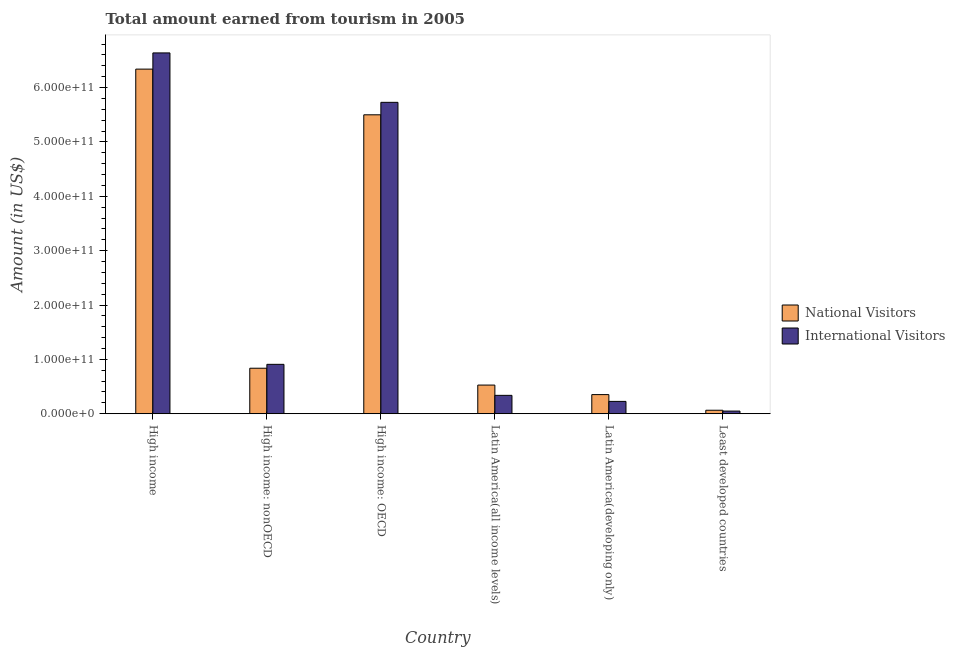How many different coloured bars are there?
Your answer should be very brief. 2. How many groups of bars are there?
Give a very brief answer. 6. Are the number of bars on each tick of the X-axis equal?
Your response must be concise. Yes. What is the label of the 4th group of bars from the left?
Make the answer very short. Latin America(all income levels). In how many cases, is the number of bars for a given country not equal to the number of legend labels?
Offer a terse response. 0. What is the amount earned from international visitors in Latin America(developing only)?
Ensure brevity in your answer.  2.27e+1. Across all countries, what is the maximum amount earned from international visitors?
Provide a succinct answer. 6.64e+11. Across all countries, what is the minimum amount earned from international visitors?
Offer a very short reply. 4.90e+09. In which country was the amount earned from international visitors minimum?
Your answer should be very brief. Least developed countries. What is the total amount earned from international visitors in the graph?
Keep it short and to the point. 1.39e+12. What is the difference between the amount earned from international visitors in High income: nonOECD and that in Latin America(developing only)?
Ensure brevity in your answer.  6.82e+1. What is the difference between the amount earned from international visitors in Latin America(developing only) and the amount earned from national visitors in High income: nonOECD?
Provide a short and direct response. -6.10e+1. What is the average amount earned from international visitors per country?
Ensure brevity in your answer.  2.31e+11. What is the difference between the amount earned from national visitors and amount earned from international visitors in Latin America(all income levels)?
Your answer should be very brief. 1.89e+1. What is the ratio of the amount earned from international visitors in High income to that in Latin America(all income levels)?
Your answer should be compact. 19.63. Is the amount earned from international visitors in High income less than that in High income: nonOECD?
Your answer should be very brief. No. Is the difference between the amount earned from national visitors in High income and Latin America(all income levels) greater than the difference between the amount earned from international visitors in High income and Latin America(all income levels)?
Offer a very short reply. No. What is the difference between the highest and the second highest amount earned from international visitors?
Make the answer very short. 9.09e+1. What is the difference between the highest and the lowest amount earned from national visitors?
Provide a succinct answer. 6.28e+11. In how many countries, is the amount earned from international visitors greater than the average amount earned from international visitors taken over all countries?
Keep it short and to the point. 2. Is the sum of the amount earned from national visitors in High income: nonOECD and Latin America(all income levels) greater than the maximum amount earned from international visitors across all countries?
Ensure brevity in your answer.  No. What does the 2nd bar from the left in Latin America(all income levels) represents?
Provide a short and direct response. International Visitors. What does the 2nd bar from the right in High income: nonOECD represents?
Give a very brief answer. National Visitors. Are all the bars in the graph horizontal?
Keep it short and to the point. No. How many countries are there in the graph?
Keep it short and to the point. 6. What is the difference between two consecutive major ticks on the Y-axis?
Your response must be concise. 1.00e+11. Does the graph contain any zero values?
Offer a very short reply. No. Does the graph contain grids?
Provide a succinct answer. No. How many legend labels are there?
Provide a short and direct response. 2. How are the legend labels stacked?
Make the answer very short. Vertical. What is the title of the graph?
Make the answer very short. Total amount earned from tourism in 2005. Does "Highest 20% of population" appear as one of the legend labels in the graph?
Provide a succinct answer. No. What is the label or title of the X-axis?
Your answer should be compact. Country. What is the Amount (in US$) in National Visitors in High income?
Provide a succinct answer. 6.34e+11. What is the Amount (in US$) in International Visitors in High income?
Keep it short and to the point. 6.64e+11. What is the Amount (in US$) of National Visitors in High income: nonOECD?
Offer a terse response. 8.37e+1. What is the Amount (in US$) of International Visitors in High income: nonOECD?
Make the answer very short. 9.09e+1. What is the Amount (in US$) of National Visitors in High income: OECD?
Offer a very short reply. 5.50e+11. What is the Amount (in US$) in International Visitors in High income: OECD?
Offer a very short reply. 5.73e+11. What is the Amount (in US$) in National Visitors in Latin America(all income levels)?
Offer a terse response. 5.27e+1. What is the Amount (in US$) in International Visitors in Latin America(all income levels)?
Provide a short and direct response. 3.38e+1. What is the Amount (in US$) in National Visitors in Latin America(developing only)?
Keep it short and to the point. 3.52e+1. What is the Amount (in US$) in International Visitors in Latin America(developing only)?
Your answer should be very brief. 2.27e+1. What is the Amount (in US$) in National Visitors in Least developed countries?
Make the answer very short. 6.44e+09. What is the Amount (in US$) of International Visitors in Least developed countries?
Offer a terse response. 4.90e+09. Across all countries, what is the maximum Amount (in US$) in National Visitors?
Your response must be concise. 6.34e+11. Across all countries, what is the maximum Amount (in US$) in International Visitors?
Keep it short and to the point. 6.64e+11. Across all countries, what is the minimum Amount (in US$) of National Visitors?
Offer a terse response. 6.44e+09. Across all countries, what is the minimum Amount (in US$) in International Visitors?
Offer a terse response. 4.90e+09. What is the total Amount (in US$) of National Visitors in the graph?
Your response must be concise. 1.36e+12. What is the total Amount (in US$) in International Visitors in the graph?
Give a very brief answer. 1.39e+12. What is the difference between the Amount (in US$) of National Visitors in High income and that in High income: nonOECD?
Offer a terse response. 5.50e+11. What is the difference between the Amount (in US$) in International Visitors in High income and that in High income: nonOECD?
Your response must be concise. 5.73e+11. What is the difference between the Amount (in US$) in National Visitors in High income and that in High income: OECD?
Keep it short and to the point. 8.40e+1. What is the difference between the Amount (in US$) in International Visitors in High income and that in High income: OECD?
Keep it short and to the point. 9.09e+1. What is the difference between the Amount (in US$) of National Visitors in High income and that in Latin America(all income levels)?
Ensure brevity in your answer.  5.81e+11. What is the difference between the Amount (in US$) of International Visitors in High income and that in Latin America(all income levels)?
Keep it short and to the point. 6.30e+11. What is the difference between the Amount (in US$) of National Visitors in High income and that in Latin America(developing only)?
Provide a succinct answer. 5.99e+11. What is the difference between the Amount (in US$) in International Visitors in High income and that in Latin America(developing only)?
Make the answer very short. 6.41e+11. What is the difference between the Amount (in US$) in National Visitors in High income and that in Least developed countries?
Give a very brief answer. 6.28e+11. What is the difference between the Amount (in US$) in International Visitors in High income and that in Least developed countries?
Your response must be concise. 6.59e+11. What is the difference between the Amount (in US$) in National Visitors in High income: nonOECD and that in High income: OECD?
Your answer should be compact. -4.66e+11. What is the difference between the Amount (in US$) of International Visitors in High income: nonOECD and that in High income: OECD?
Make the answer very short. -4.82e+11. What is the difference between the Amount (in US$) in National Visitors in High income: nonOECD and that in Latin America(all income levels)?
Keep it short and to the point. 3.10e+1. What is the difference between the Amount (in US$) of International Visitors in High income: nonOECD and that in Latin America(all income levels)?
Keep it short and to the point. 5.71e+1. What is the difference between the Amount (in US$) in National Visitors in High income: nonOECD and that in Latin America(developing only)?
Provide a short and direct response. 4.85e+1. What is the difference between the Amount (in US$) of International Visitors in High income: nonOECD and that in Latin America(developing only)?
Provide a short and direct response. 6.82e+1. What is the difference between the Amount (in US$) in National Visitors in High income: nonOECD and that in Least developed countries?
Make the answer very short. 7.73e+1. What is the difference between the Amount (in US$) in International Visitors in High income: nonOECD and that in Least developed countries?
Your answer should be very brief. 8.60e+1. What is the difference between the Amount (in US$) in National Visitors in High income: OECD and that in Latin America(all income levels)?
Your answer should be compact. 4.97e+11. What is the difference between the Amount (in US$) of International Visitors in High income: OECD and that in Latin America(all income levels)?
Your answer should be very brief. 5.39e+11. What is the difference between the Amount (in US$) of National Visitors in High income: OECD and that in Latin America(developing only)?
Make the answer very short. 5.15e+11. What is the difference between the Amount (in US$) of International Visitors in High income: OECD and that in Latin America(developing only)?
Keep it short and to the point. 5.50e+11. What is the difference between the Amount (in US$) in National Visitors in High income: OECD and that in Least developed countries?
Provide a succinct answer. 5.43e+11. What is the difference between the Amount (in US$) in International Visitors in High income: OECD and that in Least developed countries?
Give a very brief answer. 5.68e+11. What is the difference between the Amount (in US$) in National Visitors in Latin America(all income levels) and that in Latin America(developing only)?
Offer a terse response. 1.75e+1. What is the difference between the Amount (in US$) in International Visitors in Latin America(all income levels) and that in Latin America(developing only)?
Your answer should be compact. 1.11e+1. What is the difference between the Amount (in US$) in National Visitors in Latin America(all income levels) and that in Least developed countries?
Give a very brief answer. 4.63e+1. What is the difference between the Amount (in US$) of International Visitors in Latin America(all income levels) and that in Least developed countries?
Ensure brevity in your answer.  2.89e+1. What is the difference between the Amount (in US$) in National Visitors in Latin America(developing only) and that in Least developed countries?
Make the answer very short. 2.88e+1. What is the difference between the Amount (in US$) of International Visitors in Latin America(developing only) and that in Least developed countries?
Ensure brevity in your answer.  1.78e+1. What is the difference between the Amount (in US$) of National Visitors in High income and the Amount (in US$) of International Visitors in High income: nonOECD?
Offer a terse response. 5.43e+11. What is the difference between the Amount (in US$) of National Visitors in High income and the Amount (in US$) of International Visitors in High income: OECD?
Offer a terse response. 6.11e+1. What is the difference between the Amount (in US$) of National Visitors in High income and the Amount (in US$) of International Visitors in Latin America(all income levels)?
Your answer should be compact. 6.00e+11. What is the difference between the Amount (in US$) in National Visitors in High income and the Amount (in US$) in International Visitors in Latin America(developing only)?
Ensure brevity in your answer.  6.11e+11. What is the difference between the Amount (in US$) of National Visitors in High income and the Amount (in US$) of International Visitors in Least developed countries?
Make the answer very short. 6.29e+11. What is the difference between the Amount (in US$) in National Visitors in High income: nonOECD and the Amount (in US$) in International Visitors in High income: OECD?
Make the answer very short. -4.89e+11. What is the difference between the Amount (in US$) of National Visitors in High income: nonOECD and the Amount (in US$) of International Visitors in Latin America(all income levels)?
Make the answer very short. 4.99e+1. What is the difference between the Amount (in US$) of National Visitors in High income: nonOECD and the Amount (in US$) of International Visitors in Latin America(developing only)?
Give a very brief answer. 6.10e+1. What is the difference between the Amount (in US$) of National Visitors in High income: nonOECD and the Amount (in US$) of International Visitors in Least developed countries?
Your answer should be compact. 7.88e+1. What is the difference between the Amount (in US$) of National Visitors in High income: OECD and the Amount (in US$) of International Visitors in Latin America(all income levels)?
Keep it short and to the point. 5.16e+11. What is the difference between the Amount (in US$) in National Visitors in High income: OECD and the Amount (in US$) in International Visitors in Latin America(developing only)?
Make the answer very short. 5.27e+11. What is the difference between the Amount (in US$) in National Visitors in High income: OECD and the Amount (in US$) in International Visitors in Least developed countries?
Give a very brief answer. 5.45e+11. What is the difference between the Amount (in US$) of National Visitors in Latin America(all income levels) and the Amount (in US$) of International Visitors in Latin America(developing only)?
Make the answer very short. 3.00e+1. What is the difference between the Amount (in US$) in National Visitors in Latin America(all income levels) and the Amount (in US$) in International Visitors in Least developed countries?
Provide a short and direct response. 4.78e+1. What is the difference between the Amount (in US$) in National Visitors in Latin America(developing only) and the Amount (in US$) in International Visitors in Least developed countries?
Keep it short and to the point. 3.03e+1. What is the average Amount (in US$) of National Visitors per country?
Your answer should be compact. 2.27e+11. What is the average Amount (in US$) of International Visitors per country?
Make the answer very short. 2.31e+11. What is the difference between the Amount (in US$) of National Visitors and Amount (in US$) of International Visitors in High income?
Your answer should be very brief. -2.98e+1. What is the difference between the Amount (in US$) of National Visitors and Amount (in US$) of International Visitors in High income: nonOECD?
Your response must be concise. -7.16e+09. What is the difference between the Amount (in US$) of National Visitors and Amount (in US$) of International Visitors in High income: OECD?
Ensure brevity in your answer.  -2.29e+1. What is the difference between the Amount (in US$) of National Visitors and Amount (in US$) of International Visitors in Latin America(all income levels)?
Make the answer very short. 1.89e+1. What is the difference between the Amount (in US$) in National Visitors and Amount (in US$) in International Visitors in Latin America(developing only)?
Keep it short and to the point. 1.25e+1. What is the difference between the Amount (in US$) in National Visitors and Amount (in US$) in International Visitors in Least developed countries?
Make the answer very short. 1.54e+09. What is the ratio of the Amount (in US$) of National Visitors in High income to that in High income: nonOECD?
Offer a very short reply. 7.57. What is the ratio of the Amount (in US$) of International Visitors in High income to that in High income: nonOECD?
Your answer should be compact. 7.3. What is the ratio of the Amount (in US$) in National Visitors in High income to that in High income: OECD?
Provide a succinct answer. 1.15. What is the ratio of the Amount (in US$) of International Visitors in High income to that in High income: OECD?
Your response must be concise. 1.16. What is the ratio of the Amount (in US$) in National Visitors in High income to that in Latin America(all income levels)?
Your answer should be very brief. 12.02. What is the ratio of the Amount (in US$) in International Visitors in High income to that in Latin America(all income levels)?
Keep it short and to the point. 19.63. What is the ratio of the Amount (in US$) in National Visitors in High income to that in Latin America(developing only)?
Your answer should be compact. 18.01. What is the ratio of the Amount (in US$) of International Visitors in High income to that in Latin America(developing only)?
Your answer should be compact. 29.25. What is the ratio of the Amount (in US$) of National Visitors in High income to that in Least developed countries?
Give a very brief answer. 98.41. What is the ratio of the Amount (in US$) of International Visitors in High income to that in Least developed countries?
Give a very brief answer. 135.38. What is the ratio of the Amount (in US$) of National Visitors in High income: nonOECD to that in High income: OECD?
Provide a short and direct response. 0.15. What is the ratio of the Amount (in US$) of International Visitors in High income: nonOECD to that in High income: OECD?
Your answer should be very brief. 0.16. What is the ratio of the Amount (in US$) of National Visitors in High income: nonOECD to that in Latin America(all income levels)?
Make the answer very short. 1.59. What is the ratio of the Amount (in US$) of International Visitors in High income: nonOECD to that in Latin America(all income levels)?
Provide a succinct answer. 2.69. What is the ratio of the Amount (in US$) in National Visitors in High income: nonOECD to that in Latin America(developing only)?
Keep it short and to the point. 2.38. What is the ratio of the Amount (in US$) in International Visitors in High income: nonOECD to that in Latin America(developing only)?
Offer a terse response. 4. What is the ratio of the Amount (in US$) in National Visitors in High income: nonOECD to that in Least developed countries?
Offer a terse response. 13. What is the ratio of the Amount (in US$) in International Visitors in High income: nonOECD to that in Least developed countries?
Provide a short and direct response. 18.54. What is the ratio of the Amount (in US$) of National Visitors in High income: OECD to that in Latin America(all income levels)?
Your response must be concise. 10.43. What is the ratio of the Amount (in US$) in International Visitors in High income: OECD to that in Latin America(all income levels)?
Your response must be concise. 16.94. What is the ratio of the Amount (in US$) of National Visitors in High income: OECD to that in Latin America(developing only)?
Provide a succinct answer. 15.63. What is the ratio of the Amount (in US$) of International Visitors in High income: OECD to that in Latin America(developing only)?
Make the answer very short. 25.24. What is the ratio of the Amount (in US$) of National Visitors in High income: OECD to that in Least developed countries?
Ensure brevity in your answer.  85.36. What is the ratio of the Amount (in US$) in International Visitors in High income: OECD to that in Least developed countries?
Your answer should be very brief. 116.84. What is the ratio of the Amount (in US$) in National Visitors in Latin America(all income levels) to that in Latin America(developing only)?
Make the answer very short. 1.5. What is the ratio of the Amount (in US$) of International Visitors in Latin America(all income levels) to that in Latin America(developing only)?
Your response must be concise. 1.49. What is the ratio of the Amount (in US$) of National Visitors in Latin America(all income levels) to that in Least developed countries?
Your response must be concise. 8.19. What is the ratio of the Amount (in US$) of International Visitors in Latin America(all income levels) to that in Least developed countries?
Your answer should be compact. 6.9. What is the ratio of the Amount (in US$) in National Visitors in Latin America(developing only) to that in Least developed countries?
Offer a very short reply. 5.46. What is the ratio of the Amount (in US$) of International Visitors in Latin America(developing only) to that in Least developed countries?
Give a very brief answer. 4.63. What is the difference between the highest and the second highest Amount (in US$) in National Visitors?
Offer a very short reply. 8.40e+1. What is the difference between the highest and the second highest Amount (in US$) of International Visitors?
Make the answer very short. 9.09e+1. What is the difference between the highest and the lowest Amount (in US$) in National Visitors?
Offer a very short reply. 6.28e+11. What is the difference between the highest and the lowest Amount (in US$) in International Visitors?
Make the answer very short. 6.59e+11. 